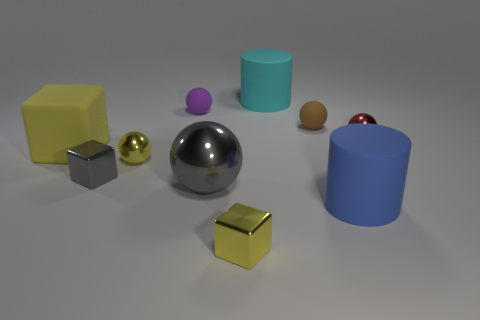Subtract all tiny brown balls. How many balls are left? 4 Subtract all red cylinders. How many yellow cubes are left? 2 Subtract all cubes. How many objects are left? 7 Subtract 2 blocks. How many blocks are left? 1 Subtract all gray blocks. How many blocks are left? 2 Add 5 yellow spheres. How many yellow spheres are left? 6 Add 4 purple shiny objects. How many purple shiny objects exist? 4 Subtract 0 brown cubes. How many objects are left? 10 Subtract all yellow cylinders. Subtract all brown balls. How many cylinders are left? 2 Subtract all brown cylinders. Subtract all gray cubes. How many objects are left? 9 